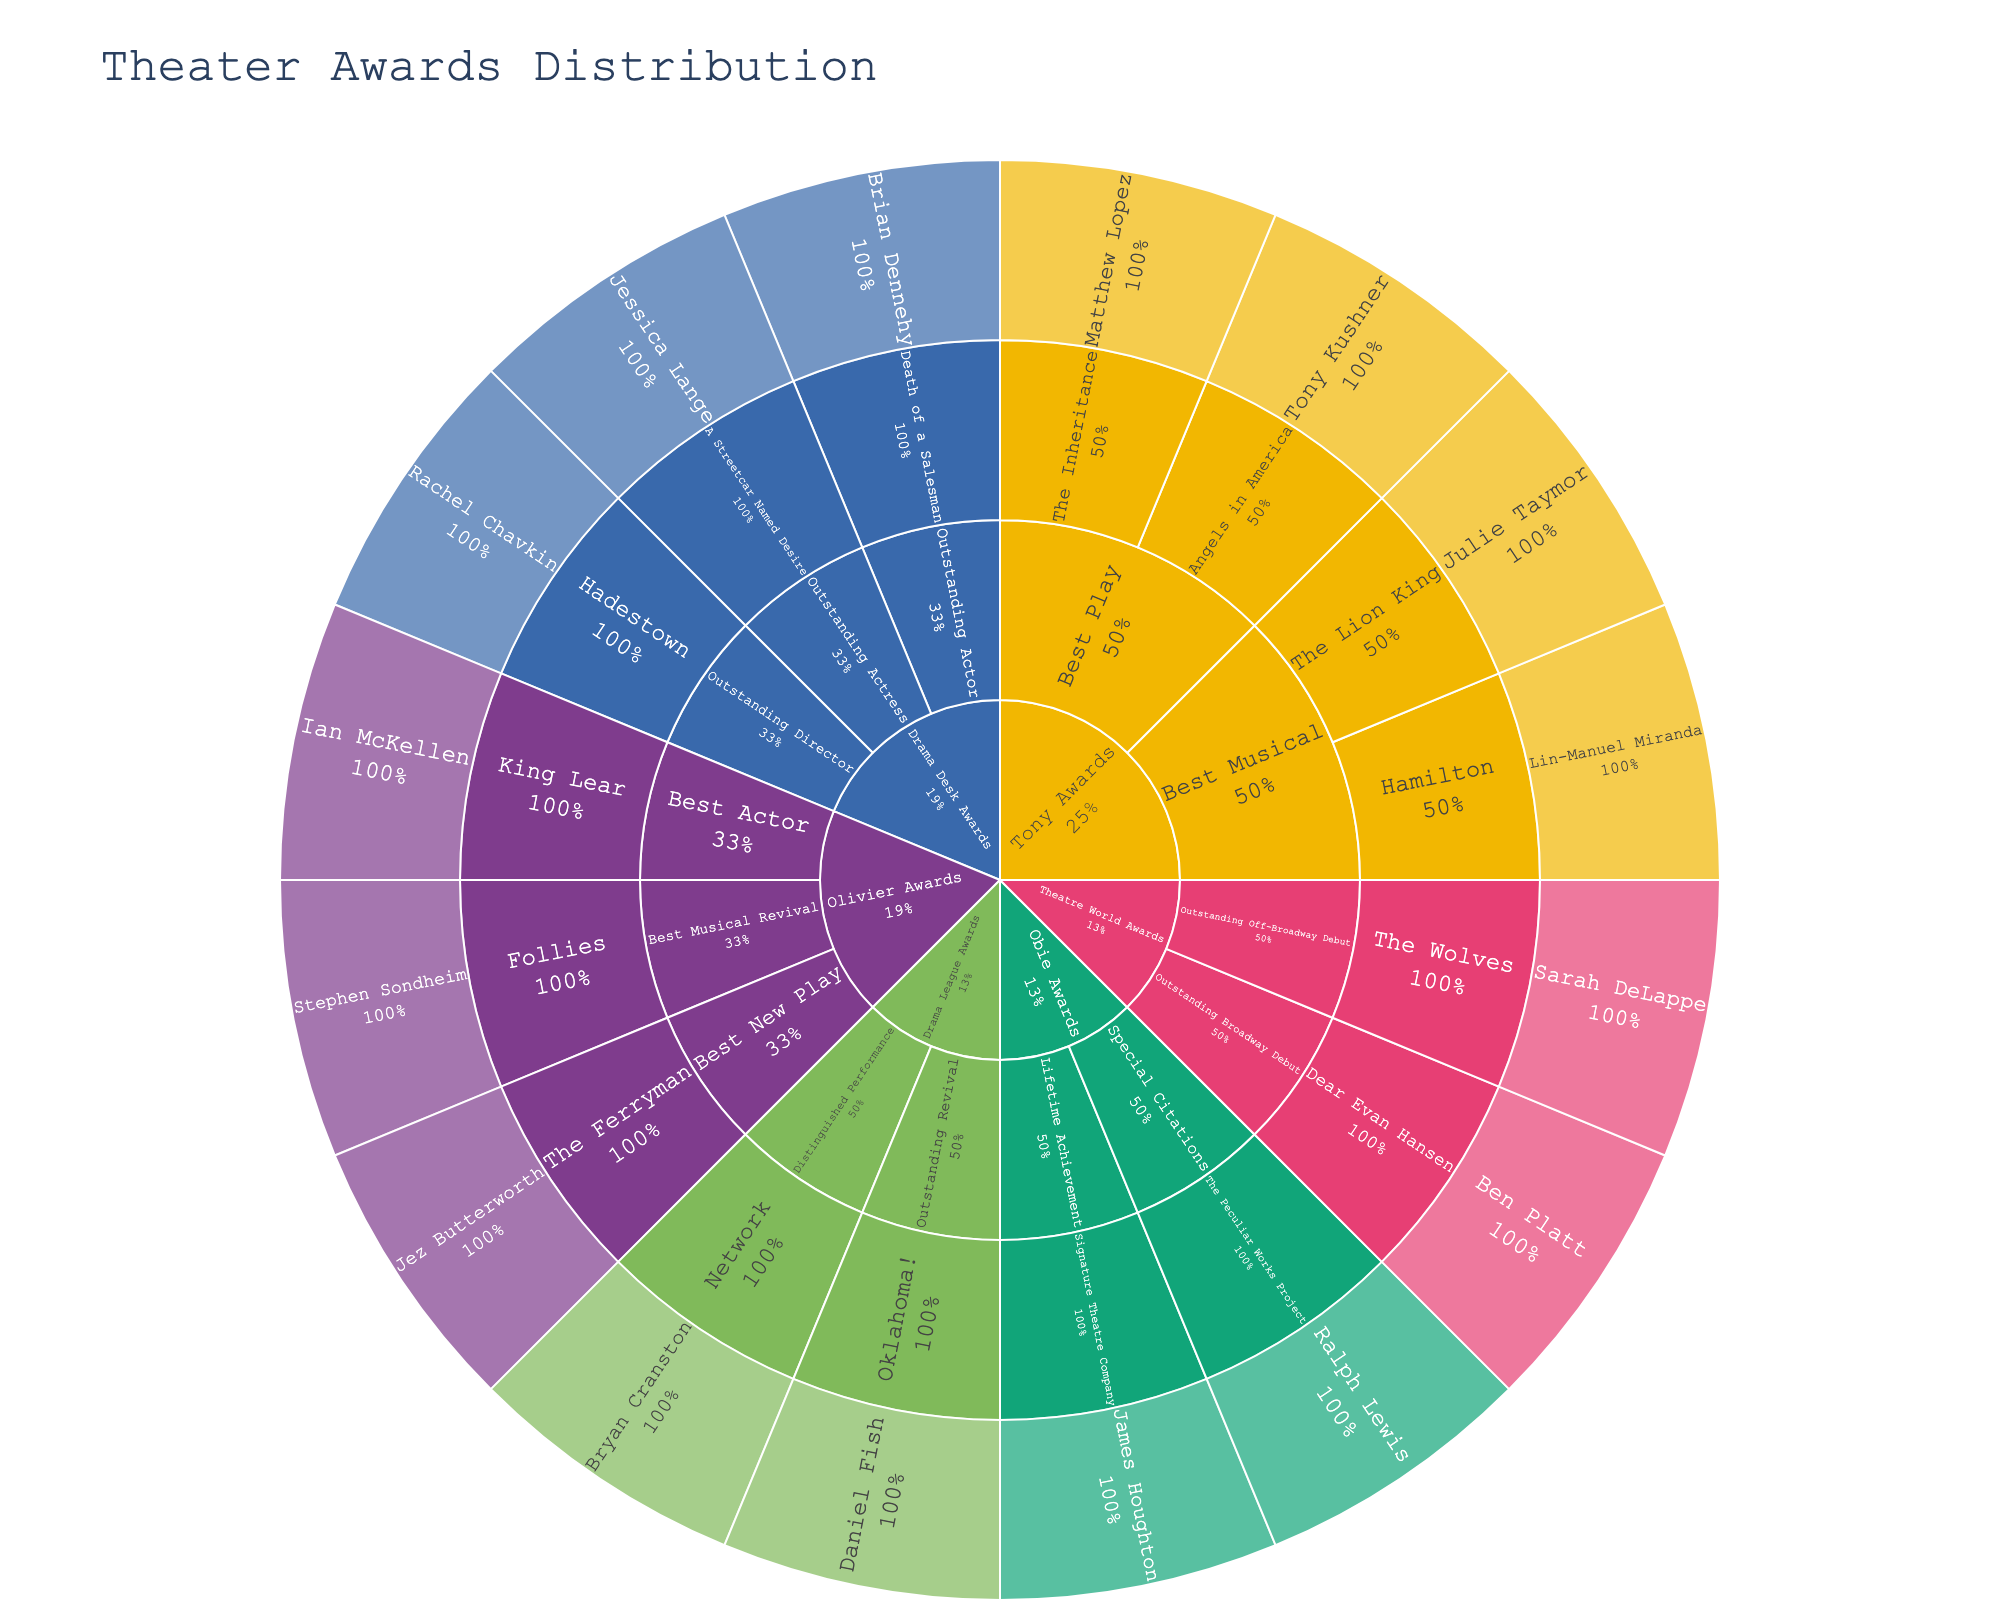What is the title of the sunburst plot? The title is located at the top of the figure in a larger font than other text, which indicates the main topic or purpose of the visualization.
Answer: Theater Awards Distribution How many main award categories are shown in the plot? By identifying the distinct segments at the outermost ring at the first level (the largest level), we count the unique categories.
Answer: 5 Which award categories have subcategories listed for them? Observe the second level of segments branching out from the main categories to see which ones split further.
Answer: Tony Awards, Drama Desk Awards, Olivier Awards, Theatre World Awards, Obie Awards, Drama League Awards (all listed categories) Who won the Drama League Award for Distinguished Performance? Drill down into the Drama League Awards, then move into the Distinguished Performance subcategory to find the recipient.
Answer: Bryan Cranston What percentage of the Tony Awards section does 'Best Musical' take up? Find the Tony Awards section, identify the slice for Best Musical, and compare it to the other segments within the Tony Awards section to estimate the percentage.
Answer: Approximately 50% How many individuals have been awarded within the Drama Desk Awards category? Count the segments branching from the Drama Desk Awards category at a deeper level to tally the awards recipients.
Answer: 3 Which award has the most diverse winners? Check each award category and its subcategories to see which has the most unique recipient names listed.
Answer: Tony Awards (different winners in each subcategory) Which production in the Drama Desk Awards category received an award for Outstanding Actor? Examine the Drama Desk Awards section, navigate to the Outstanding Actor subcategory, and identify the production listed there.
Answer: Death of a Salesman Compare the number of recipients in the Drama League Awards and Obie Awards categories. Which category has more recipients? Count the segments at the recipient level for both Drama League Awards and Obie Awards, then compare the totals.
Answer: Drama League Awards have more recipients (2 vs. 2) How many recipients are there in total across all categories? Sum up all the segments at the deepest level across all categories where recipients are named.
Answer: 15 